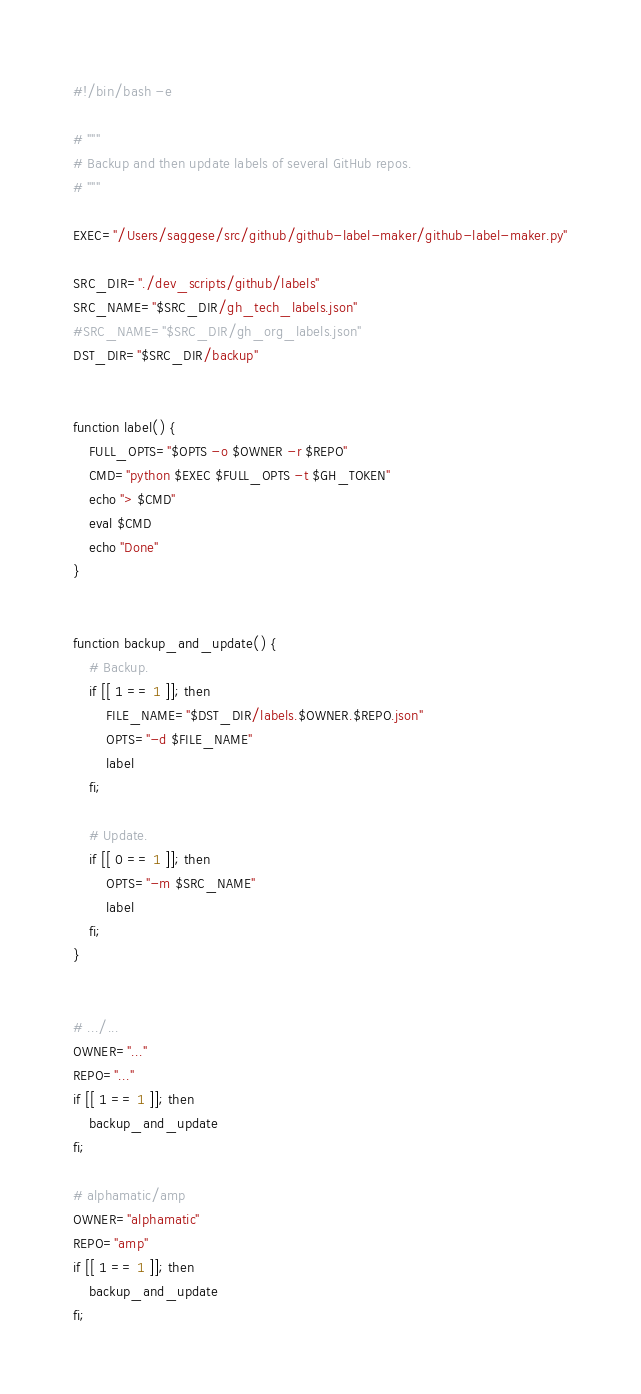<code> <loc_0><loc_0><loc_500><loc_500><_Bash_>#!/bin/bash -e

# """
# Backup and then update labels of several GitHub repos.
# """

EXEC="/Users/saggese/src/github/github-label-maker/github-label-maker.py"

SRC_DIR="./dev_scripts/github/labels"
SRC_NAME="$SRC_DIR/gh_tech_labels.json"
#SRC_NAME="$SRC_DIR/gh_org_labels.json"
DST_DIR="$SRC_DIR/backup"


function label() {
    FULL_OPTS="$OPTS -o $OWNER -r $REPO"
    CMD="python $EXEC $FULL_OPTS -t $GH_TOKEN"
    echo "> $CMD"
    eval $CMD
    echo "Done"
}


function backup_and_update() {
    # Backup.
    if [[ 1 == 1 ]]; then
        FILE_NAME="$DST_DIR/labels.$OWNER.$REPO.json"
        OPTS="-d $FILE_NAME"
        label
    fi;

    # Update.
    if [[ 0 == 1 ]]; then
        OPTS="-m $SRC_NAME"
        label
    fi;
}


# .../...
OWNER="..."
REPO="..."
if [[ 1 == 1 ]]; then
    backup_and_update
fi;

# alphamatic/amp
OWNER="alphamatic"
REPO="amp"
if [[ 1 == 1 ]]; then
    backup_and_update
fi;
</code> 